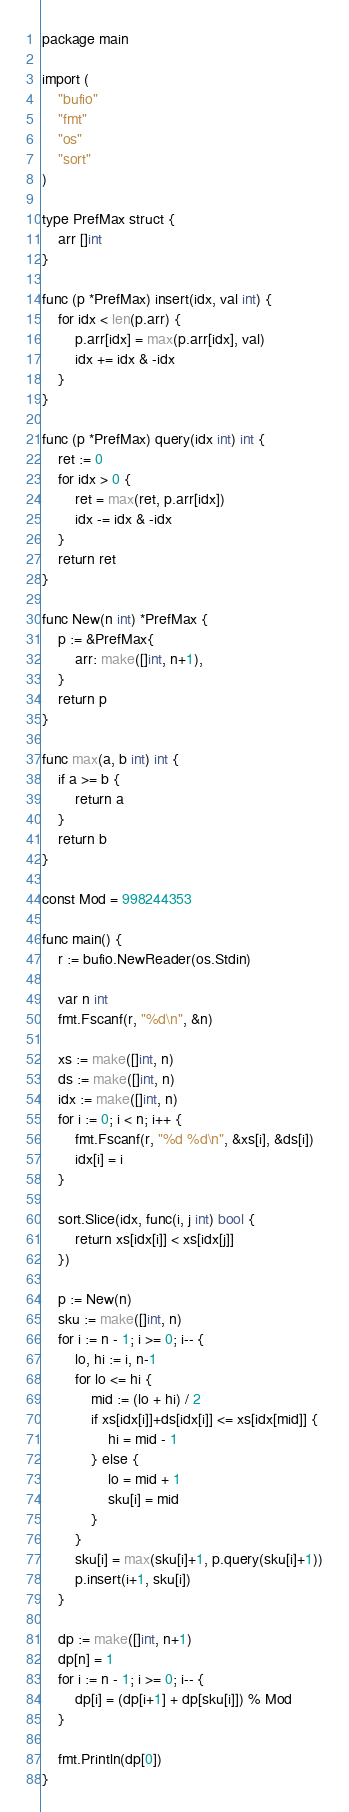<code> <loc_0><loc_0><loc_500><loc_500><_Go_>package main

import (
	"bufio"
	"fmt"
	"os"
	"sort"
)

type PrefMax struct {
	arr []int
}

func (p *PrefMax) insert(idx, val int) {
	for idx < len(p.arr) {
		p.arr[idx] = max(p.arr[idx], val)
		idx += idx & -idx
	}
}

func (p *PrefMax) query(idx int) int {
	ret := 0
	for idx > 0 {
		ret = max(ret, p.arr[idx])
		idx -= idx & -idx
	}
	return ret
}

func New(n int) *PrefMax {
	p := &PrefMax{
		arr: make([]int, n+1),
	}
	return p
}

func max(a, b int) int {
	if a >= b {
		return a
	}
	return b
}

const Mod = 998244353

func main() {
	r := bufio.NewReader(os.Stdin)

	var n int
	fmt.Fscanf(r, "%d\n", &n)

	xs := make([]int, n)
	ds := make([]int, n)
	idx := make([]int, n)
	for i := 0; i < n; i++ {
		fmt.Fscanf(r, "%d %d\n", &xs[i], &ds[i])
		idx[i] = i
	}

	sort.Slice(idx, func(i, j int) bool {
		return xs[idx[i]] < xs[idx[j]]
	})

	p := New(n)
	sku := make([]int, n)
	for i := n - 1; i >= 0; i-- {
		lo, hi := i, n-1
		for lo <= hi {
			mid := (lo + hi) / 2
			if xs[idx[i]]+ds[idx[i]] <= xs[idx[mid]] {
				hi = mid - 1
			} else {
				lo = mid + 1
				sku[i] = mid
			}
		}
		sku[i] = max(sku[i]+1, p.query(sku[i]+1))
		p.insert(i+1, sku[i])
	}

	dp := make([]int, n+1)
	dp[n] = 1
	for i := n - 1; i >= 0; i-- {
		dp[i] = (dp[i+1] + dp[sku[i]]) % Mod
	}

	fmt.Println(dp[0])
}
</code> 